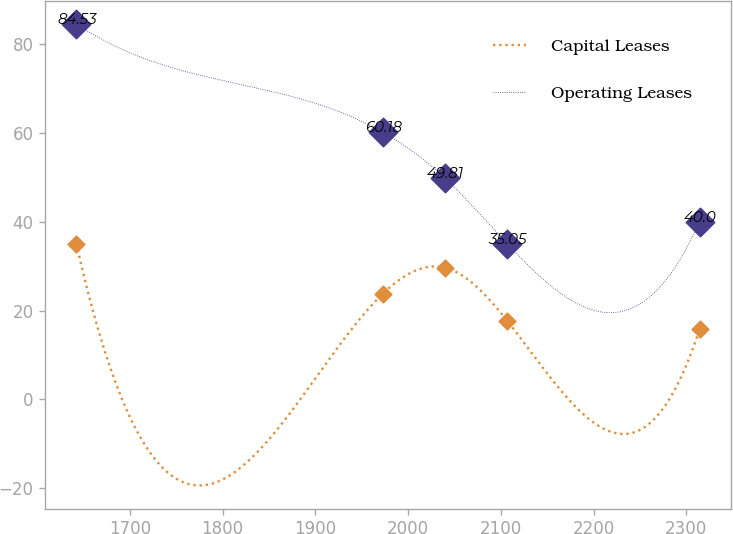Convert chart. <chart><loc_0><loc_0><loc_500><loc_500><line_chart><ecel><fcel>Capital Leases<fcel>Operating Leases<nl><fcel>1642.34<fcel>35.05<fcel>84.53<nl><fcel>1972.56<fcel>23.74<fcel>60.18<nl><fcel>2039.75<fcel>29.67<fcel>49.81<nl><fcel>2106.94<fcel>17.69<fcel>35.05<nl><fcel>2314.25<fcel>15.76<fcel>40<nl></chart> 